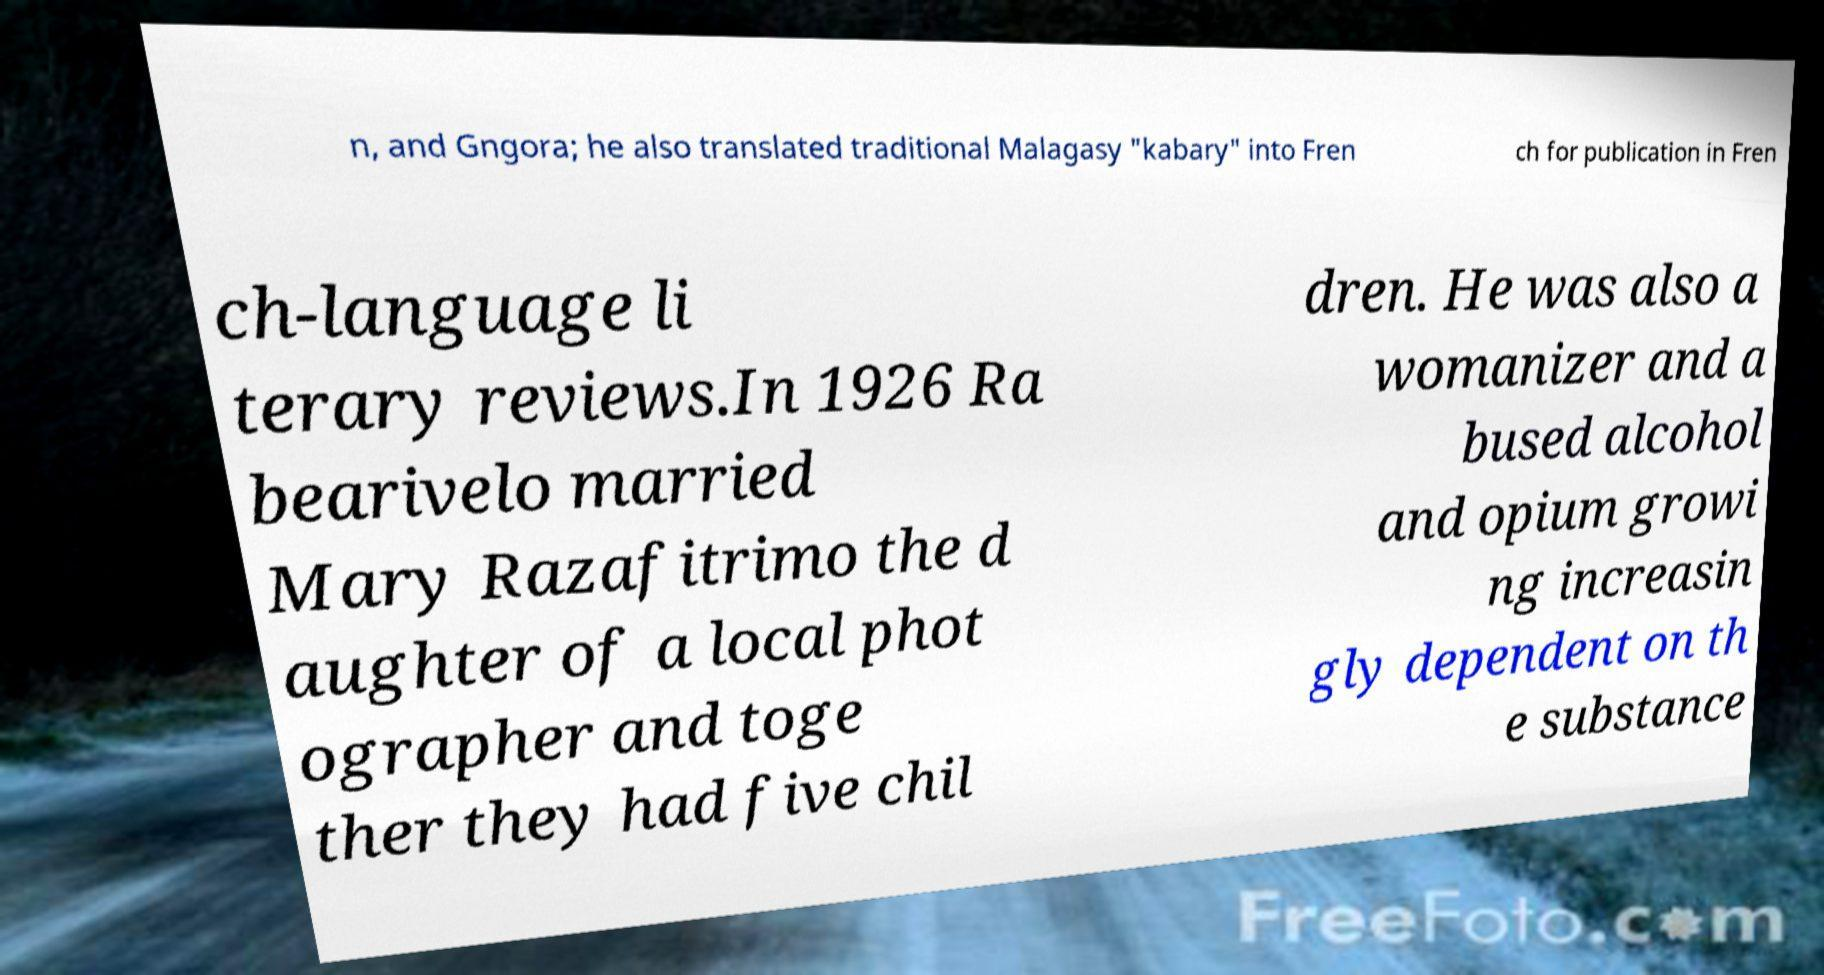Could you extract and type out the text from this image? n, and Gngora; he also translated traditional Malagasy "kabary" into Fren ch for publication in Fren ch-language li terary reviews.In 1926 Ra bearivelo married Mary Razafitrimo the d aughter of a local phot ographer and toge ther they had five chil dren. He was also a womanizer and a bused alcohol and opium growi ng increasin gly dependent on th e substance 